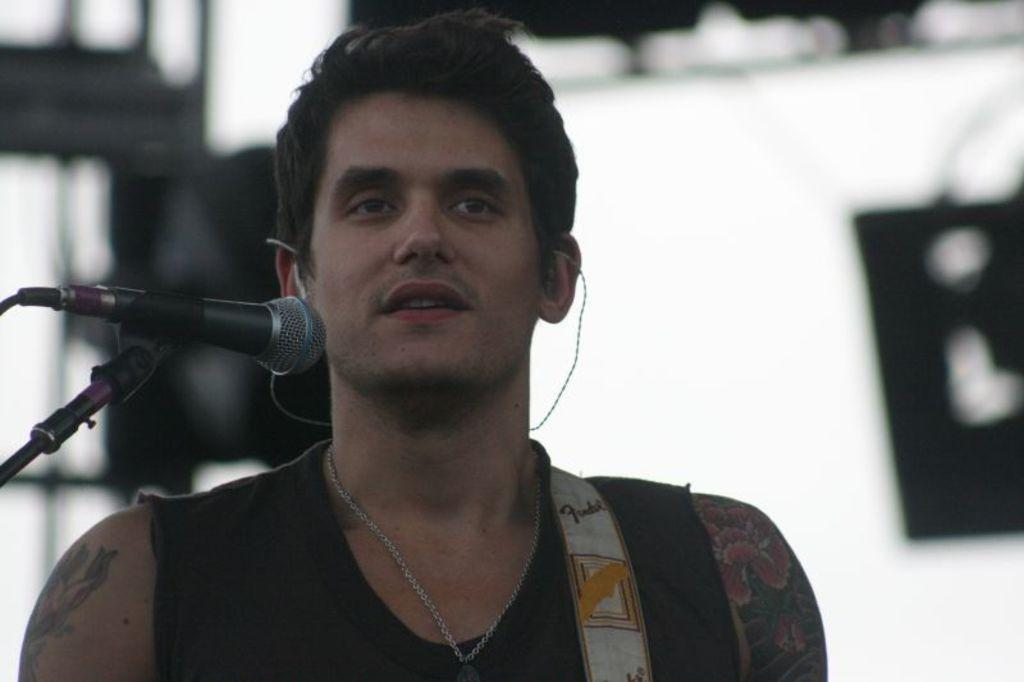What is the main subject of the image? There is a person in the image. What is the person doing in the image? The person is standing and talking into a microphone. Can you describe the background of the image? The background of the image appears blurred. What date is circled on the calendar in the image? There is no calendar present in the image. What type of map can be seen in the background of the image? There is no map present in the image; the background appears blurred. 